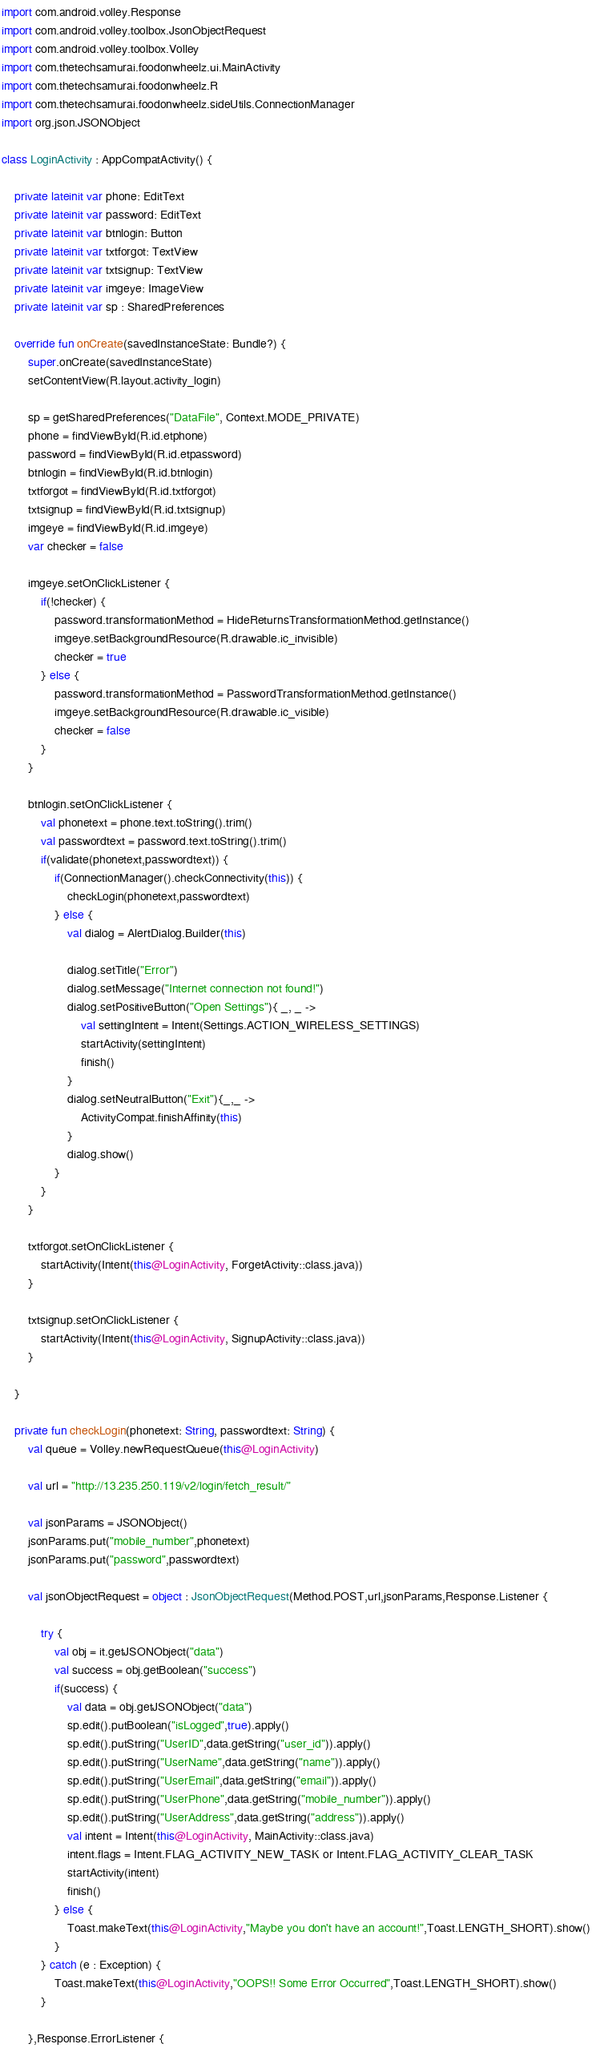Convert code to text. <code><loc_0><loc_0><loc_500><loc_500><_Kotlin_>import com.android.volley.Response
import com.android.volley.toolbox.JsonObjectRequest
import com.android.volley.toolbox.Volley
import com.thetechsamurai.foodonwheelz.ui.MainActivity
import com.thetechsamurai.foodonwheelz.R
import com.thetechsamurai.foodonwheelz.sideUtils.ConnectionManager
import org.json.JSONObject

class LoginActivity : AppCompatActivity() {

    private lateinit var phone: EditText
    private lateinit var password: EditText
    private lateinit var btnlogin: Button
    private lateinit var txtforgot: TextView
    private lateinit var txtsignup: TextView
    private lateinit var imgeye: ImageView
    private lateinit var sp : SharedPreferences

    override fun onCreate(savedInstanceState: Bundle?) {
        super.onCreate(savedInstanceState)
        setContentView(R.layout.activity_login)

        sp = getSharedPreferences("DataFile", Context.MODE_PRIVATE)
        phone = findViewById(R.id.etphone)
        password = findViewById(R.id.etpassword)
        btnlogin = findViewById(R.id.btnlogin)
        txtforgot = findViewById(R.id.txtforgot)
        txtsignup = findViewById(R.id.txtsignup)
        imgeye = findViewById(R.id.imgeye)
        var checker = false

        imgeye.setOnClickListener {
            if(!checker) {
                password.transformationMethod = HideReturnsTransformationMethod.getInstance()
                imgeye.setBackgroundResource(R.drawable.ic_invisible)
                checker = true
            } else {
                password.transformationMethod = PasswordTransformationMethod.getInstance()
                imgeye.setBackgroundResource(R.drawable.ic_visible)
                checker = false
            }
        }

        btnlogin.setOnClickListener {
            val phonetext = phone.text.toString().trim()
            val passwordtext = password.text.toString().trim()
            if(validate(phonetext,passwordtext)) {
                if(ConnectionManager().checkConnectivity(this)) {
                    checkLogin(phonetext,passwordtext)
                } else {
                    val dialog = AlertDialog.Builder(this)

                    dialog.setTitle("Error")
                    dialog.setMessage("Internet connection not found!")
                    dialog.setPositiveButton("Open Settings"){ _, _ ->
                        val settingIntent = Intent(Settings.ACTION_WIRELESS_SETTINGS)
                        startActivity(settingIntent)
                        finish()
                    }
                    dialog.setNeutralButton("Exit"){_,_ ->
                        ActivityCompat.finishAffinity(this)
                    }
                    dialog.show()
                }
            }
        }

        txtforgot.setOnClickListener {
            startActivity(Intent(this@LoginActivity, ForgetActivity::class.java))
        }

        txtsignup.setOnClickListener {
            startActivity(Intent(this@LoginActivity, SignupActivity::class.java))
        }

    }

    private fun checkLogin(phonetext: String, passwordtext: String) {
        val queue = Volley.newRequestQueue(this@LoginActivity)

        val url = "http://13.235.250.119/v2/login/fetch_result/"

        val jsonParams = JSONObject()
        jsonParams.put("mobile_number",phonetext)
        jsonParams.put("password",passwordtext)

        val jsonObjectRequest = object : JsonObjectRequest(Method.POST,url,jsonParams,Response.Listener {

            try {
                val obj = it.getJSONObject("data")
                val success = obj.getBoolean("success")
                if(success) {
                    val data = obj.getJSONObject("data")
                    sp.edit().putBoolean("isLogged",true).apply()
                    sp.edit().putString("UserID",data.getString("user_id")).apply()
                    sp.edit().putString("UserName",data.getString("name")).apply()
                    sp.edit().putString("UserEmail",data.getString("email")).apply()
                    sp.edit().putString("UserPhone",data.getString("mobile_number")).apply()
                    sp.edit().putString("UserAddress",data.getString("address")).apply()
                    val intent = Intent(this@LoginActivity, MainActivity::class.java)
                    intent.flags = Intent.FLAG_ACTIVITY_NEW_TASK or Intent.FLAG_ACTIVITY_CLEAR_TASK
                    startActivity(intent)
                    finish()
                } else {
                    Toast.makeText(this@LoginActivity,"Maybe you don't have an account!",Toast.LENGTH_SHORT).show()
                }
            } catch (e : Exception) {
                Toast.makeText(this@LoginActivity,"OOPS!! Some Error Occurred",Toast.LENGTH_SHORT).show()
            }

        },Response.ErrorListener {</code> 